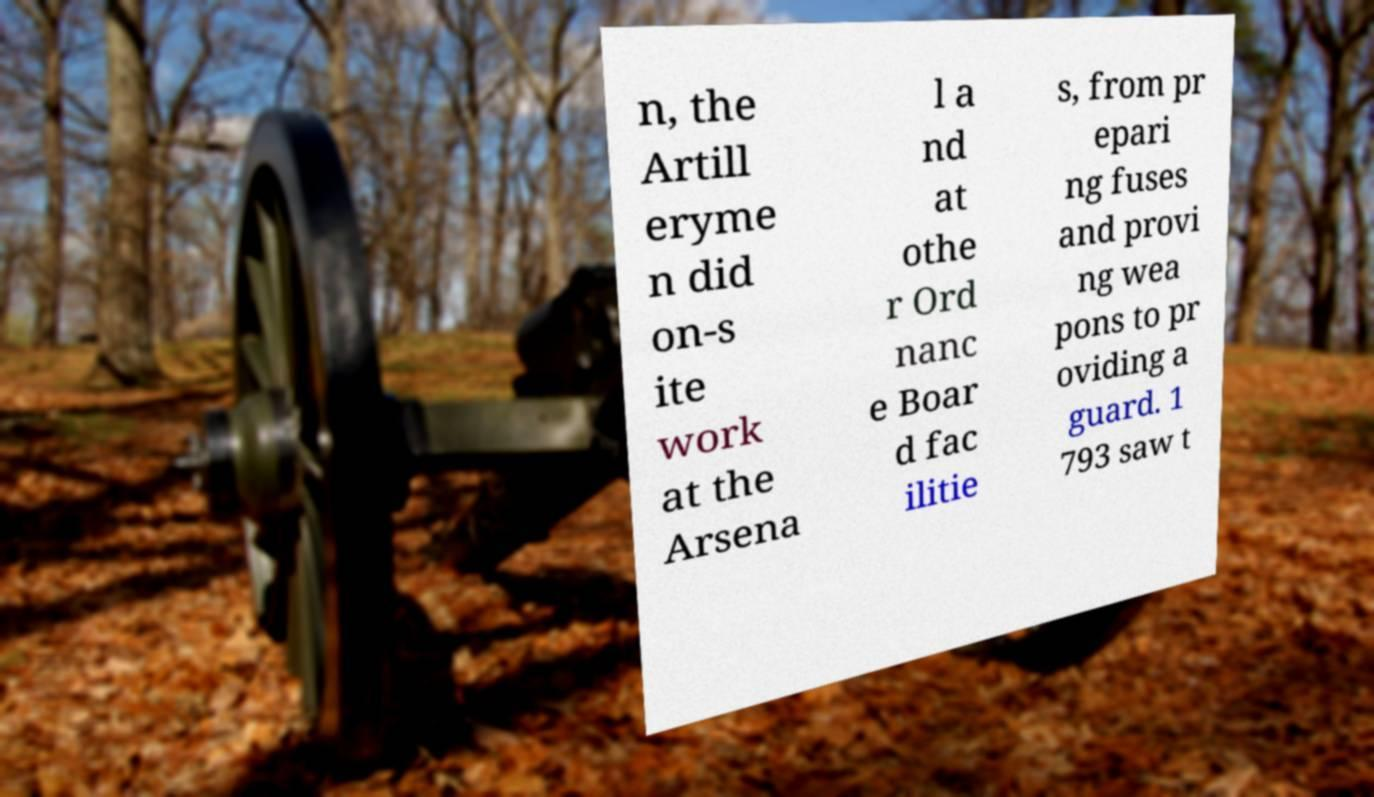Can you accurately transcribe the text from the provided image for me? n, the Artill eryme n did on-s ite work at the Arsena l a nd at othe r Ord nanc e Boar d fac ilitie s, from pr epari ng fuses and provi ng wea pons to pr oviding a guard. 1 793 saw t 